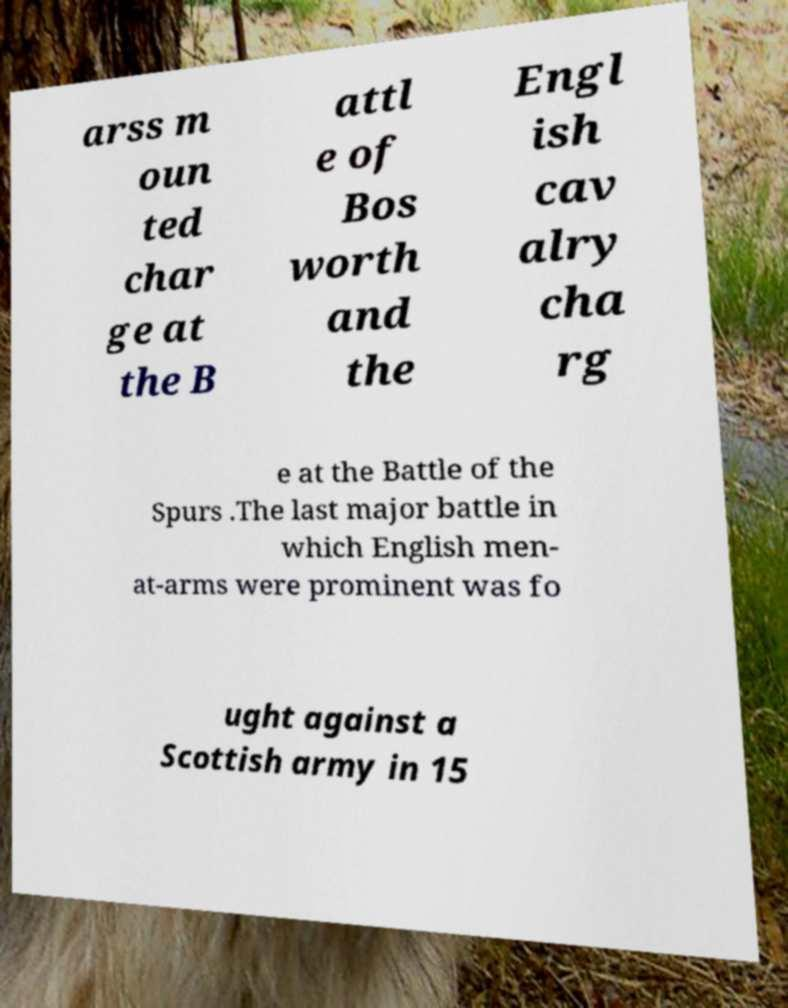I need the written content from this picture converted into text. Can you do that? arss m oun ted char ge at the B attl e of Bos worth and the Engl ish cav alry cha rg e at the Battle of the Spurs .The last major battle in which English men- at-arms were prominent was fo ught against a Scottish army in 15 